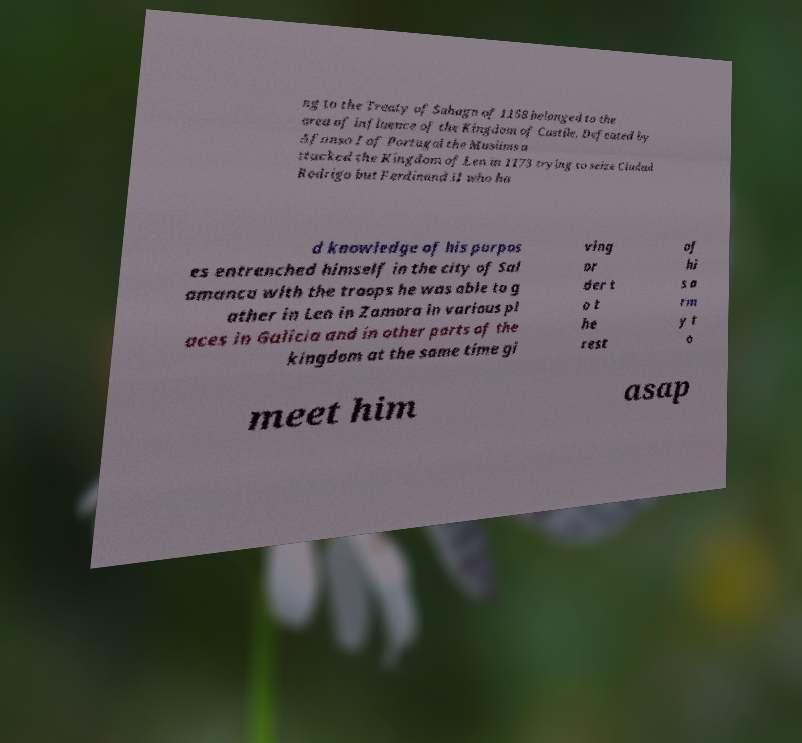For documentation purposes, I need the text within this image transcribed. Could you provide that? ng to the Treaty of Sahagn of 1158 belonged to the area of influence of the Kingdom of Castile. Defeated by Afonso I of Portugal the Muslims a ttacked the Kingdom of Len in 1173 trying to seize Ciudad Rodrigo but Ferdinand II who ha d knowledge of his purpos es entrenched himself in the city of Sal amanca with the troops he was able to g ather in Len in Zamora in various pl aces in Galicia and in other parts of the kingdom at the same time gi ving or der t o t he rest of hi s a rm y t o meet him asap 